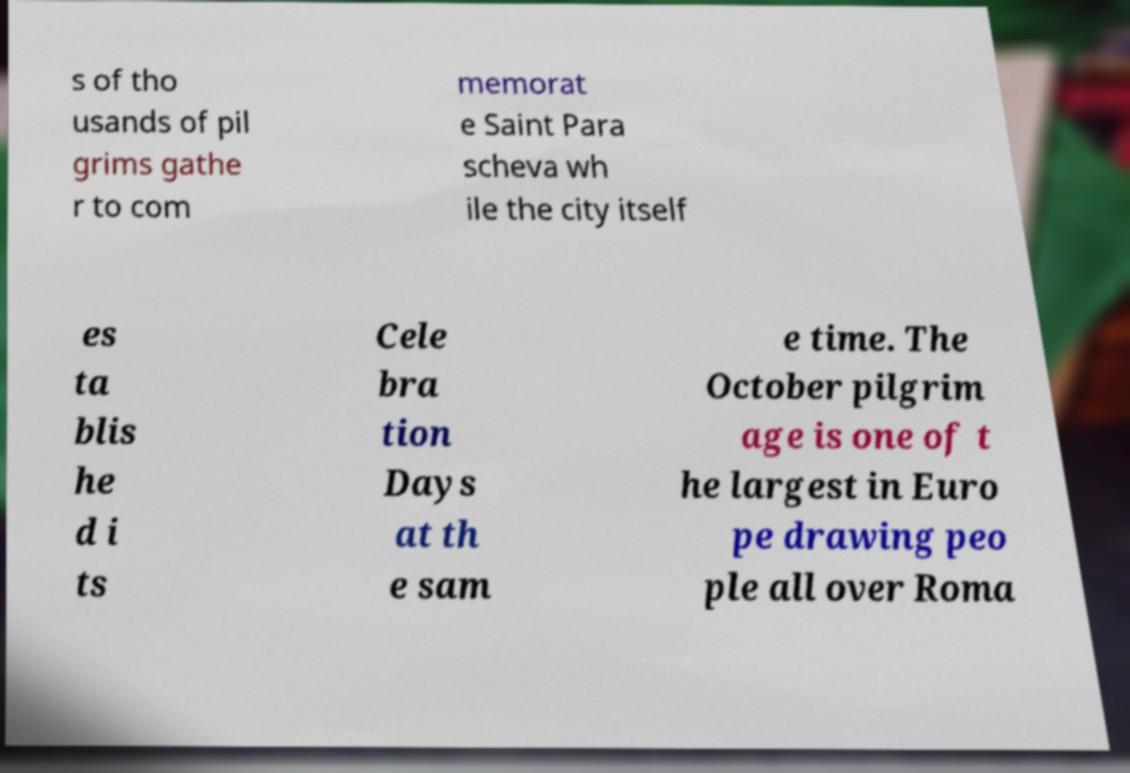Could you assist in decoding the text presented in this image and type it out clearly? s of tho usands of pil grims gathe r to com memorat e Saint Para scheva wh ile the city itself es ta blis he d i ts Cele bra tion Days at th e sam e time. The October pilgrim age is one of t he largest in Euro pe drawing peo ple all over Roma 